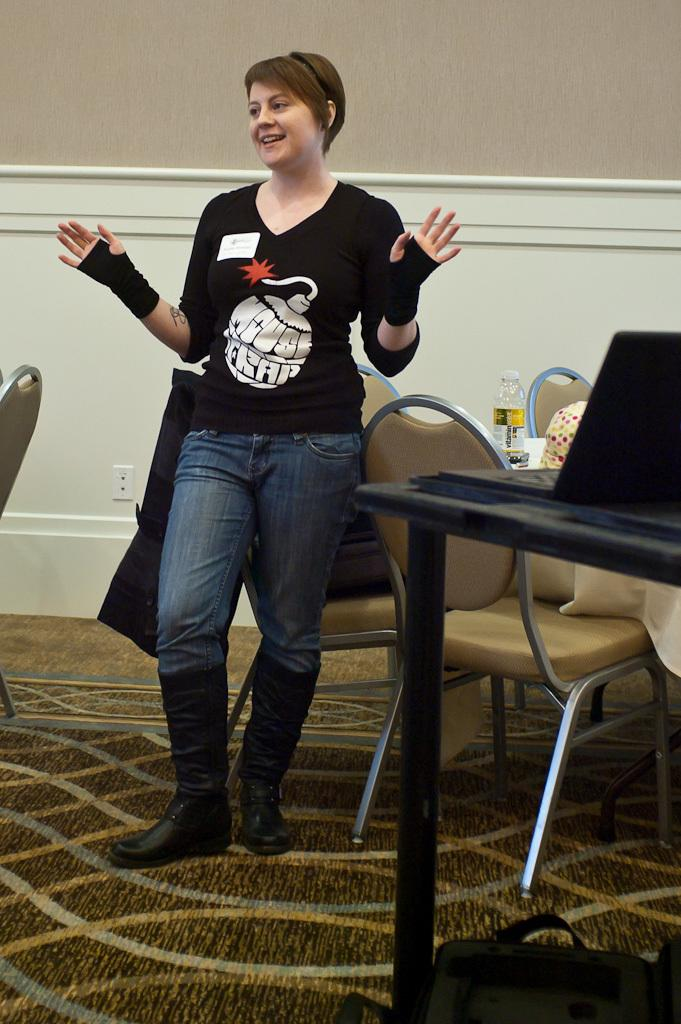What is the woman doing in the image? The woman is standing in the image. How does the woman appear in the image? The woman has a smile on her face. What can be seen in the background of the image? There are chairs and a table in the background of the image. What is on the table in the image? There is a laptop on the table. What type of crate can be seen in the image? There is no crate present in the image. 